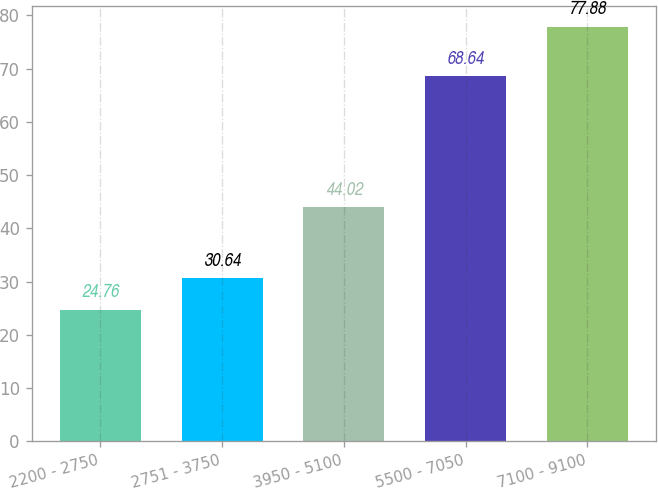<chart> <loc_0><loc_0><loc_500><loc_500><bar_chart><fcel>2200 - 2750<fcel>2751 - 3750<fcel>3950 - 5100<fcel>5500 - 7050<fcel>7100 - 9100<nl><fcel>24.76<fcel>30.64<fcel>44.02<fcel>68.64<fcel>77.88<nl></chart> 